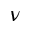<formula> <loc_0><loc_0><loc_500><loc_500>\nu</formula> 